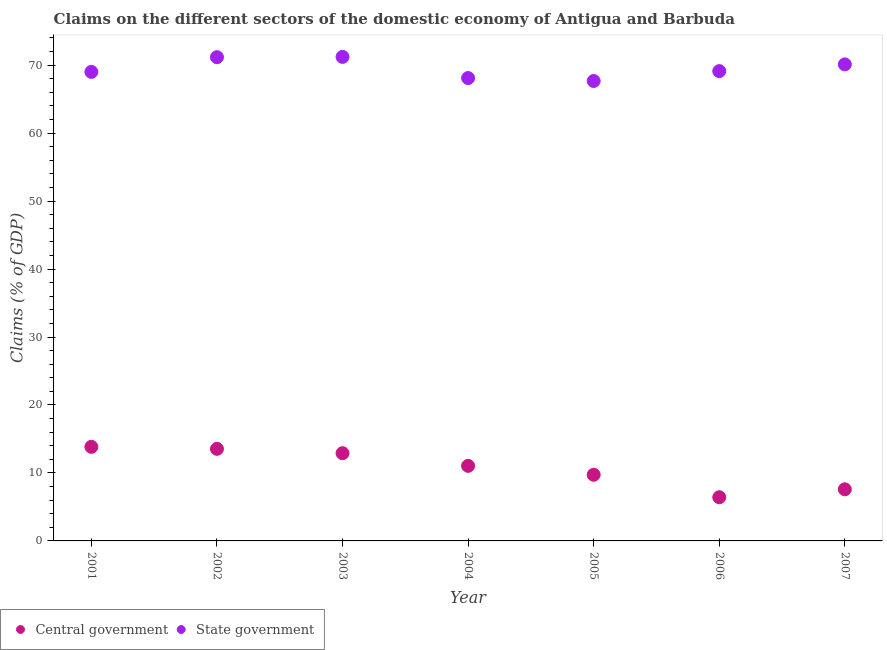How many different coloured dotlines are there?
Your response must be concise. 2. Is the number of dotlines equal to the number of legend labels?
Your response must be concise. Yes. What is the claims on central government in 2001?
Your response must be concise. 13.84. Across all years, what is the maximum claims on state government?
Offer a very short reply. 71.21. Across all years, what is the minimum claims on central government?
Give a very brief answer. 6.43. In which year was the claims on state government maximum?
Ensure brevity in your answer.  2003. In which year was the claims on state government minimum?
Your answer should be very brief. 2005. What is the total claims on state government in the graph?
Keep it short and to the point. 486.36. What is the difference between the claims on state government in 2001 and that in 2005?
Your response must be concise. 1.34. What is the difference between the claims on state government in 2006 and the claims on central government in 2004?
Your answer should be compact. 58.08. What is the average claims on state government per year?
Offer a very short reply. 69.48. In the year 2002, what is the difference between the claims on state government and claims on central government?
Offer a terse response. 57.62. What is the ratio of the claims on state government in 2006 to that in 2007?
Your answer should be compact. 0.99. What is the difference between the highest and the second highest claims on state government?
Provide a short and direct response. 0.04. What is the difference between the highest and the lowest claims on state government?
Make the answer very short. 3.55. Is the sum of the claims on state government in 2003 and 2006 greater than the maximum claims on central government across all years?
Offer a terse response. Yes. Does the claims on state government monotonically increase over the years?
Offer a terse response. No. Is the claims on state government strictly greater than the claims on central government over the years?
Provide a short and direct response. Yes. How many years are there in the graph?
Your answer should be very brief. 7. Are the values on the major ticks of Y-axis written in scientific E-notation?
Your answer should be very brief. No. Does the graph contain any zero values?
Your response must be concise. No. Where does the legend appear in the graph?
Keep it short and to the point. Bottom left. How many legend labels are there?
Your response must be concise. 2. What is the title of the graph?
Provide a short and direct response. Claims on the different sectors of the domestic economy of Antigua and Barbuda. What is the label or title of the X-axis?
Provide a succinct answer. Year. What is the label or title of the Y-axis?
Provide a short and direct response. Claims (% of GDP). What is the Claims (% of GDP) in Central government in 2001?
Offer a terse response. 13.84. What is the Claims (% of GDP) of State government in 2001?
Offer a very short reply. 69. What is the Claims (% of GDP) of Central government in 2002?
Make the answer very short. 13.55. What is the Claims (% of GDP) in State government in 2002?
Offer a terse response. 71.17. What is the Claims (% of GDP) of Central government in 2003?
Offer a very short reply. 12.91. What is the Claims (% of GDP) in State government in 2003?
Offer a terse response. 71.21. What is the Claims (% of GDP) in Central government in 2004?
Provide a short and direct response. 11.04. What is the Claims (% of GDP) in State government in 2004?
Ensure brevity in your answer.  68.09. What is the Claims (% of GDP) in Central government in 2005?
Provide a succinct answer. 9.73. What is the Claims (% of GDP) in State government in 2005?
Give a very brief answer. 67.66. What is the Claims (% of GDP) in Central government in 2006?
Give a very brief answer. 6.43. What is the Claims (% of GDP) of State government in 2006?
Your answer should be compact. 69.12. What is the Claims (% of GDP) in Central government in 2007?
Provide a short and direct response. 7.59. What is the Claims (% of GDP) in State government in 2007?
Keep it short and to the point. 70.11. Across all years, what is the maximum Claims (% of GDP) of Central government?
Offer a very short reply. 13.84. Across all years, what is the maximum Claims (% of GDP) of State government?
Provide a succinct answer. 71.21. Across all years, what is the minimum Claims (% of GDP) of Central government?
Provide a short and direct response. 6.43. Across all years, what is the minimum Claims (% of GDP) in State government?
Offer a terse response. 67.66. What is the total Claims (% of GDP) of Central government in the graph?
Provide a succinct answer. 75.09. What is the total Claims (% of GDP) of State government in the graph?
Make the answer very short. 486.36. What is the difference between the Claims (% of GDP) in Central government in 2001 and that in 2002?
Offer a terse response. 0.29. What is the difference between the Claims (% of GDP) of State government in 2001 and that in 2002?
Give a very brief answer. -2.16. What is the difference between the Claims (% of GDP) in Central government in 2001 and that in 2003?
Provide a succinct answer. 0.94. What is the difference between the Claims (% of GDP) in State government in 2001 and that in 2003?
Ensure brevity in your answer.  -2.21. What is the difference between the Claims (% of GDP) in Central government in 2001 and that in 2004?
Keep it short and to the point. 2.8. What is the difference between the Claims (% of GDP) of State government in 2001 and that in 2004?
Your response must be concise. 0.91. What is the difference between the Claims (% of GDP) in Central government in 2001 and that in 2005?
Your answer should be compact. 4.11. What is the difference between the Claims (% of GDP) of State government in 2001 and that in 2005?
Provide a succinct answer. 1.34. What is the difference between the Claims (% of GDP) of Central government in 2001 and that in 2006?
Provide a succinct answer. 7.41. What is the difference between the Claims (% of GDP) in State government in 2001 and that in 2006?
Offer a very short reply. -0.12. What is the difference between the Claims (% of GDP) in Central government in 2001 and that in 2007?
Provide a short and direct response. 6.25. What is the difference between the Claims (% of GDP) of State government in 2001 and that in 2007?
Ensure brevity in your answer.  -1.11. What is the difference between the Claims (% of GDP) in Central government in 2002 and that in 2003?
Make the answer very short. 0.64. What is the difference between the Claims (% of GDP) in State government in 2002 and that in 2003?
Give a very brief answer. -0.04. What is the difference between the Claims (% of GDP) in Central government in 2002 and that in 2004?
Keep it short and to the point. 2.51. What is the difference between the Claims (% of GDP) in State government in 2002 and that in 2004?
Offer a very short reply. 3.07. What is the difference between the Claims (% of GDP) of Central government in 2002 and that in 2005?
Ensure brevity in your answer.  3.82. What is the difference between the Claims (% of GDP) of State government in 2002 and that in 2005?
Give a very brief answer. 3.5. What is the difference between the Claims (% of GDP) of Central government in 2002 and that in 2006?
Offer a terse response. 7.12. What is the difference between the Claims (% of GDP) in State government in 2002 and that in 2006?
Provide a succinct answer. 2.05. What is the difference between the Claims (% of GDP) in Central government in 2002 and that in 2007?
Give a very brief answer. 5.95. What is the difference between the Claims (% of GDP) of State government in 2002 and that in 2007?
Your response must be concise. 1.06. What is the difference between the Claims (% of GDP) of Central government in 2003 and that in 2004?
Your answer should be compact. 1.86. What is the difference between the Claims (% of GDP) in State government in 2003 and that in 2004?
Provide a short and direct response. 3.11. What is the difference between the Claims (% of GDP) in Central government in 2003 and that in 2005?
Your answer should be compact. 3.18. What is the difference between the Claims (% of GDP) of State government in 2003 and that in 2005?
Your response must be concise. 3.55. What is the difference between the Claims (% of GDP) in Central government in 2003 and that in 2006?
Make the answer very short. 6.48. What is the difference between the Claims (% of GDP) in State government in 2003 and that in 2006?
Make the answer very short. 2.09. What is the difference between the Claims (% of GDP) in Central government in 2003 and that in 2007?
Provide a short and direct response. 5.31. What is the difference between the Claims (% of GDP) in State government in 2003 and that in 2007?
Offer a very short reply. 1.1. What is the difference between the Claims (% of GDP) of Central government in 2004 and that in 2005?
Provide a short and direct response. 1.31. What is the difference between the Claims (% of GDP) in State government in 2004 and that in 2005?
Keep it short and to the point. 0.43. What is the difference between the Claims (% of GDP) in Central government in 2004 and that in 2006?
Your answer should be compact. 4.62. What is the difference between the Claims (% of GDP) in State government in 2004 and that in 2006?
Keep it short and to the point. -1.02. What is the difference between the Claims (% of GDP) in Central government in 2004 and that in 2007?
Provide a short and direct response. 3.45. What is the difference between the Claims (% of GDP) in State government in 2004 and that in 2007?
Make the answer very short. -2.01. What is the difference between the Claims (% of GDP) in Central government in 2005 and that in 2006?
Offer a very short reply. 3.3. What is the difference between the Claims (% of GDP) in State government in 2005 and that in 2006?
Give a very brief answer. -1.46. What is the difference between the Claims (% of GDP) in Central government in 2005 and that in 2007?
Offer a terse response. 2.14. What is the difference between the Claims (% of GDP) in State government in 2005 and that in 2007?
Make the answer very short. -2.45. What is the difference between the Claims (% of GDP) in Central government in 2006 and that in 2007?
Offer a very short reply. -1.17. What is the difference between the Claims (% of GDP) of State government in 2006 and that in 2007?
Give a very brief answer. -0.99. What is the difference between the Claims (% of GDP) of Central government in 2001 and the Claims (% of GDP) of State government in 2002?
Make the answer very short. -57.32. What is the difference between the Claims (% of GDP) of Central government in 2001 and the Claims (% of GDP) of State government in 2003?
Your response must be concise. -57.37. What is the difference between the Claims (% of GDP) in Central government in 2001 and the Claims (% of GDP) in State government in 2004?
Make the answer very short. -54.25. What is the difference between the Claims (% of GDP) of Central government in 2001 and the Claims (% of GDP) of State government in 2005?
Provide a succinct answer. -53.82. What is the difference between the Claims (% of GDP) in Central government in 2001 and the Claims (% of GDP) in State government in 2006?
Offer a very short reply. -55.28. What is the difference between the Claims (% of GDP) of Central government in 2001 and the Claims (% of GDP) of State government in 2007?
Offer a terse response. -56.27. What is the difference between the Claims (% of GDP) in Central government in 2002 and the Claims (% of GDP) in State government in 2003?
Provide a succinct answer. -57.66. What is the difference between the Claims (% of GDP) of Central government in 2002 and the Claims (% of GDP) of State government in 2004?
Your response must be concise. -54.55. What is the difference between the Claims (% of GDP) in Central government in 2002 and the Claims (% of GDP) in State government in 2005?
Keep it short and to the point. -54.11. What is the difference between the Claims (% of GDP) of Central government in 2002 and the Claims (% of GDP) of State government in 2006?
Give a very brief answer. -55.57. What is the difference between the Claims (% of GDP) of Central government in 2002 and the Claims (% of GDP) of State government in 2007?
Ensure brevity in your answer.  -56.56. What is the difference between the Claims (% of GDP) of Central government in 2003 and the Claims (% of GDP) of State government in 2004?
Your answer should be compact. -55.19. What is the difference between the Claims (% of GDP) of Central government in 2003 and the Claims (% of GDP) of State government in 2005?
Your answer should be compact. -54.76. What is the difference between the Claims (% of GDP) of Central government in 2003 and the Claims (% of GDP) of State government in 2006?
Give a very brief answer. -56.21. What is the difference between the Claims (% of GDP) of Central government in 2003 and the Claims (% of GDP) of State government in 2007?
Provide a succinct answer. -57.2. What is the difference between the Claims (% of GDP) of Central government in 2004 and the Claims (% of GDP) of State government in 2005?
Your response must be concise. -56.62. What is the difference between the Claims (% of GDP) in Central government in 2004 and the Claims (% of GDP) in State government in 2006?
Your answer should be compact. -58.08. What is the difference between the Claims (% of GDP) of Central government in 2004 and the Claims (% of GDP) of State government in 2007?
Ensure brevity in your answer.  -59.06. What is the difference between the Claims (% of GDP) of Central government in 2005 and the Claims (% of GDP) of State government in 2006?
Ensure brevity in your answer.  -59.39. What is the difference between the Claims (% of GDP) of Central government in 2005 and the Claims (% of GDP) of State government in 2007?
Your answer should be very brief. -60.38. What is the difference between the Claims (% of GDP) in Central government in 2006 and the Claims (% of GDP) in State government in 2007?
Ensure brevity in your answer.  -63.68. What is the average Claims (% of GDP) in Central government per year?
Give a very brief answer. 10.73. What is the average Claims (% of GDP) of State government per year?
Make the answer very short. 69.48. In the year 2001, what is the difference between the Claims (% of GDP) in Central government and Claims (% of GDP) in State government?
Keep it short and to the point. -55.16. In the year 2002, what is the difference between the Claims (% of GDP) in Central government and Claims (% of GDP) in State government?
Keep it short and to the point. -57.62. In the year 2003, what is the difference between the Claims (% of GDP) of Central government and Claims (% of GDP) of State government?
Your answer should be compact. -58.3. In the year 2004, what is the difference between the Claims (% of GDP) of Central government and Claims (% of GDP) of State government?
Offer a terse response. -57.05. In the year 2005, what is the difference between the Claims (% of GDP) in Central government and Claims (% of GDP) in State government?
Your answer should be compact. -57.93. In the year 2006, what is the difference between the Claims (% of GDP) of Central government and Claims (% of GDP) of State government?
Ensure brevity in your answer.  -62.69. In the year 2007, what is the difference between the Claims (% of GDP) in Central government and Claims (% of GDP) in State government?
Ensure brevity in your answer.  -62.51. What is the ratio of the Claims (% of GDP) in Central government in 2001 to that in 2002?
Your response must be concise. 1.02. What is the ratio of the Claims (% of GDP) of State government in 2001 to that in 2002?
Your response must be concise. 0.97. What is the ratio of the Claims (% of GDP) of Central government in 2001 to that in 2003?
Your response must be concise. 1.07. What is the ratio of the Claims (% of GDP) in State government in 2001 to that in 2003?
Offer a terse response. 0.97. What is the ratio of the Claims (% of GDP) in Central government in 2001 to that in 2004?
Offer a terse response. 1.25. What is the ratio of the Claims (% of GDP) in State government in 2001 to that in 2004?
Provide a succinct answer. 1.01. What is the ratio of the Claims (% of GDP) in Central government in 2001 to that in 2005?
Provide a succinct answer. 1.42. What is the ratio of the Claims (% of GDP) of State government in 2001 to that in 2005?
Provide a short and direct response. 1.02. What is the ratio of the Claims (% of GDP) of Central government in 2001 to that in 2006?
Keep it short and to the point. 2.15. What is the ratio of the Claims (% of GDP) of Central government in 2001 to that in 2007?
Give a very brief answer. 1.82. What is the ratio of the Claims (% of GDP) of State government in 2001 to that in 2007?
Make the answer very short. 0.98. What is the ratio of the Claims (% of GDP) in Central government in 2002 to that in 2003?
Provide a short and direct response. 1.05. What is the ratio of the Claims (% of GDP) in Central government in 2002 to that in 2004?
Provide a succinct answer. 1.23. What is the ratio of the Claims (% of GDP) of State government in 2002 to that in 2004?
Provide a short and direct response. 1.05. What is the ratio of the Claims (% of GDP) of Central government in 2002 to that in 2005?
Provide a succinct answer. 1.39. What is the ratio of the Claims (% of GDP) in State government in 2002 to that in 2005?
Make the answer very short. 1.05. What is the ratio of the Claims (% of GDP) of Central government in 2002 to that in 2006?
Make the answer very short. 2.11. What is the ratio of the Claims (% of GDP) of State government in 2002 to that in 2006?
Offer a very short reply. 1.03. What is the ratio of the Claims (% of GDP) in Central government in 2002 to that in 2007?
Provide a succinct answer. 1.78. What is the ratio of the Claims (% of GDP) of State government in 2002 to that in 2007?
Provide a short and direct response. 1.02. What is the ratio of the Claims (% of GDP) in Central government in 2003 to that in 2004?
Give a very brief answer. 1.17. What is the ratio of the Claims (% of GDP) of State government in 2003 to that in 2004?
Make the answer very short. 1.05. What is the ratio of the Claims (% of GDP) in Central government in 2003 to that in 2005?
Provide a short and direct response. 1.33. What is the ratio of the Claims (% of GDP) in State government in 2003 to that in 2005?
Provide a short and direct response. 1.05. What is the ratio of the Claims (% of GDP) of Central government in 2003 to that in 2006?
Make the answer very short. 2.01. What is the ratio of the Claims (% of GDP) in State government in 2003 to that in 2006?
Your answer should be very brief. 1.03. What is the ratio of the Claims (% of GDP) of Central government in 2003 to that in 2007?
Provide a short and direct response. 1.7. What is the ratio of the Claims (% of GDP) in State government in 2003 to that in 2007?
Your answer should be very brief. 1.02. What is the ratio of the Claims (% of GDP) in Central government in 2004 to that in 2005?
Keep it short and to the point. 1.13. What is the ratio of the Claims (% of GDP) in State government in 2004 to that in 2005?
Ensure brevity in your answer.  1.01. What is the ratio of the Claims (% of GDP) in Central government in 2004 to that in 2006?
Offer a very short reply. 1.72. What is the ratio of the Claims (% of GDP) of State government in 2004 to that in 2006?
Your response must be concise. 0.99. What is the ratio of the Claims (% of GDP) of Central government in 2004 to that in 2007?
Ensure brevity in your answer.  1.45. What is the ratio of the Claims (% of GDP) in State government in 2004 to that in 2007?
Your response must be concise. 0.97. What is the ratio of the Claims (% of GDP) of Central government in 2005 to that in 2006?
Offer a terse response. 1.51. What is the ratio of the Claims (% of GDP) of State government in 2005 to that in 2006?
Offer a terse response. 0.98. What is the ratio of the Claims (% of GDP) in Central government in 2005 to that in 2007?
Keep it short and to the point. 1.28. What is the ratio of the Claims (% of GDP) in State government in 2005 to that in 2007?
Provide a short and direct response. 0.97. What is the ratio of the Claims (% of GDP) of Central government in 2006 to that in 2007?
Offer a terse response. 0.85. What is the ratio of the Claims (% of GDP) in State government in 2006 to that in 2007?
Make the answer very short. 0.99. What is the difference between the highest and the second highest Claims (% of GDP) of Central government?
Provide a succinct answer. 0.29. What is the difference between the highest and the second highest Claims (% of GDP) in State government?
Ensure brevity in your answer.  0.04. What is the difference between the highest and the lowest Claims (% of GDP) in Central government?
Ensure brevity in your answer.  7.41. What is the difference between the highest and the lowest Claims (% of GDP) in State government?
Provide a succinct answer. 3.55. 